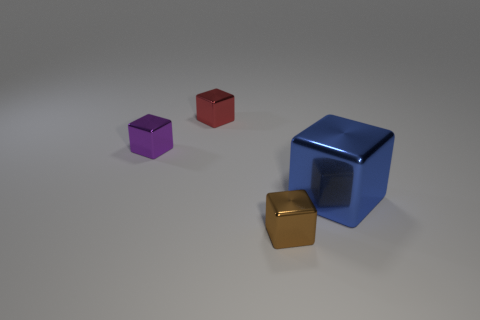Add 1 small cyan blocks. How many objects exist? 5 Subtract all small red matte cubes. Subtract all big objects. How many objects are left? 3 Add 2 large blue metal cubes. How many large blue metal cubes are left? 3 Add 2 shiny blocks. How many shiny blocks exist? 6 Subtract 0 cyan cubes. How many objects are left? 4 